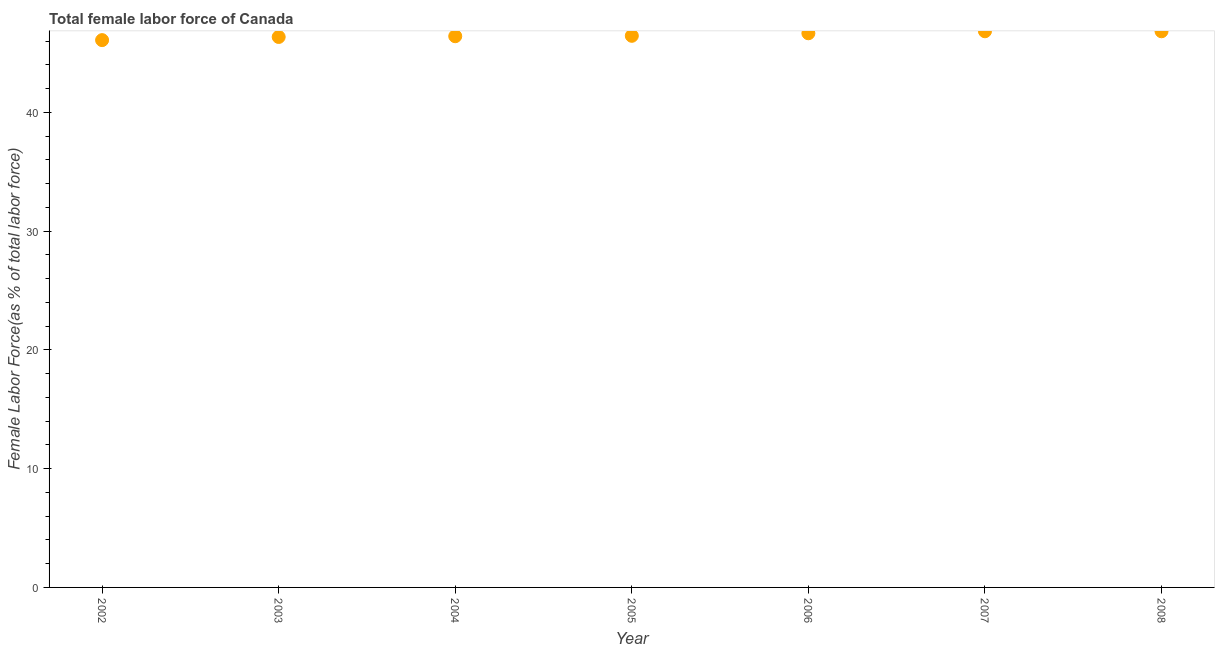What is the total female labor force in 2008?
Keep it short and to the point. 46.84. Across all years, what is the maximum total female labor force?
Offer a terse response. 46.84. Across all years, what is the minimum total female labor force?
Give a very brief answer. 46.09. In which year was the total female labor force minimum?
Your response must be concise. 2002. What is the sum of the total female labor force?
Your response must be concise. 325.67. What is the difference between the total female labor force in 2004 and 2005?
Your answer should be very brief. -0.03. What is the average total female labor force per year?
Your answer should be very brief. 46.52. What is the median total female labor force?
Keep it short and to the point. 46.45. In how many years, is the total female labor force greater than 42 %?
Your response must be concise. 7. Do a majority of the years between 2005 and 2004 (inclusive) have total female labor force greater than 40 %?
Ensure brevity in your answer.  No. What is the ratio of the total female labor force in 2005 to that in 2007?
Your response must be concise. 0.99. Is the total female labor force in 2003 less than that in 2008?
Keep it short and to the point. Yes. What is the difference between the highest and the second highest total female labor force?
Offer a very short reply. 0. What is the difference between the highest and the lowest total female labor force?
Keep it short and to the point. 0.75. In how many years, is the total female labor force greater than the average total female labor force taken over all years?
Give a very brief answer. 3. How many dotlines are there?
Give a very brief answer. 1. How many years are there in the graph?
Provide a succinct answer. 7. What is the title of the graph?
Your response must be concise. Total female labor force of Canada. What is the label or title of the Y-axis?
Provide a short and direct response. Female Labor Force(as % of total labor force). What is the Female Labor Force(as % of total labor force) in 2002?
Provide a short and direct response. 46.09. What is the Female Labor Force(as % of total labor force) in 2003?
Ensure brevity in your answer.  46.36. What is the Female Labor Force(as % of total labor force) in 2004?
Keep it short and to the point. 46.42. What is the Female Labor Force(as % of total labor force) in 2005?
Give a very brief answer. 46.45. What is the Female Labor Force(as % of total labor force) in 2006?
Ensure brevity in your answer.  46.67. What is the Female Labor Force(as % of total labor force) in 2007?
Provide a succinct answer. 46.84. What is the Female Labor Force(as % of total labor force) in 2008?
Give a very brief answer. 46.84. What is the difference between the Female Labor Force(as % of total labor force) in 2002 and 2003?
Give a very brief answer. -0.27. What is the difference between the Female Labor Force(as % of total labor force) in 2002 and 2004?
Your answer should be very brief. -0.33. What is the difference between the Female Labor Force(as % of total labor force) in 2002 and 2005?
Provide a short and direct response. -0.36. What is the difference between the Female Labor Force(as % of total labor force) in 2002 and 2006?
Your response must be concise. -0.58. What is the difference between the Female Labor Force(as % of total labor force) in 2002 and 2007?
Your answer should be compact. -0.75. What is the difference between the Female Labor Force(as % of total labor force) in 2002 and 2008?
Ensure brevity in your answer.  -0.74. What is the difference between the Female Labor Force(as % of total labor force) in 2003 and 2004?
Provide a short and direct response. -0.06. What is the difference between the Female Labor Force(as % of total labor force) in 2003 and 2005?
Ensure brevity in your answer.  -0.1. What is the difference between the Female Labor Force(as % of total labor force) in 2003 and 2006?
Offer a terse response. -0.31. What is the difference between the Female Labor Force(as % of total labor force) in 2003 and 2007?
Provide a short and direct response. -0.48. What is the difference between the Female Labor Force(as % of total labor force) in 2003 and 2008?
Provide a succinct answer. -0.48. What is the difference between the Female Labor Force(as % of total labor force) in 2004 and 2005?
Your answer should be compact. -0.03. What is the difference between the Female Labor Force(as % of total labor force) in 2004 and 2006?
Keep it short and to the point. -0.25. What is the difference between the Female Labor Force(as % of total labor force) in 2004 and 2007?
Make the answer very short. -0.42. What is the difference between the Female Labor Force(as % of total labor force) in 2004 and 2008?
Your answer should be compact. -0.42. What is the difference between the Female Labor Force(as % of total labor force) in 2005 and 2006?
Offer a very short reply. -0.21. What is the difference between the Female Labor Force(as % of total labor force) in 2005 and 2007?
Your response must be concise. -0.38. What is the difference between the Female Labor Force(as % of total labor force) in 2005 and 2008?
Offer a very short reply. -0.38. What is the difference between the Female Labor Force(as % of total labor force) in 2006 and 2007?
Your answer should be very brief. -0.17. What is the difference between the Female Labor Force(as % of total labor force) in 2006 and 2008?
Ensure brevity in your answer.  -0.17. What is the difference between the Female Labor Force(as % of total labor force) in 2007 and 2008?
Make the answer very short. 0. What is the ratio of the Female Labor Force(as % of total labor force) in 2002 to that in 2005?
Offer a very short reply. 0.99. What is the ratio of the Female Labor Force(as % of total labor force) in 2002 to that in 2008?
Give a very brief answer. 0.98. What is the ratio of the Female Labor Force(as % of total labor force) in 2003 to that in 2004?
Give a very brief answer. 1. What is the ratio of the Female Labor Force(as % of total labor force) in 2003 to that in 2005?
Your answer should be compact. 1. What is the ratio of the Female Labor Force(as % of total labor force) in 2003 to that in 2006?
Provide a short and direct response. 0.99. What is the ratio of the Female Labor Force(as % of total labor force) in 2003 to that in 2007?
Offer a very short reply. 0.99. What is the ratio of the Female Labor Force(as % of total labor force) in 2003 to that in 2008?
Your response must be concise. 0.99. What is the ratio of the Female Labor Force(as % of total labor force) in 2004 to that in 2005?
Offer a terse response. 1. What is the ratio of the Female Labor Force(as % of total labor force) in 2004 to that in 2006?
Make the answer very short. 0.99. What is the ratio of the Female Labor Force(as % of total labor force) in 2004 to that in 2007?
Your response must be concise. 0.99. What is the ratio of the Female Labor Force(as % of total labor force) in 2004 to that in 2008?
Provide a short and direct response. 0.99. What is the ratio of the Female Labor Force(as % of total labor force) in 2005 to that in 2007?
Ensure brevity in your answer.  0.99. What is the ratio of the Female Labor Force(as % of total labor force) in 2006 to that in 2007?
Offer a very short reply. 1. What is the ratio of the Female Labor Force(as % of total labor force) in 2006 to that in 2008?
Ensure brevity in your answer.  1. 